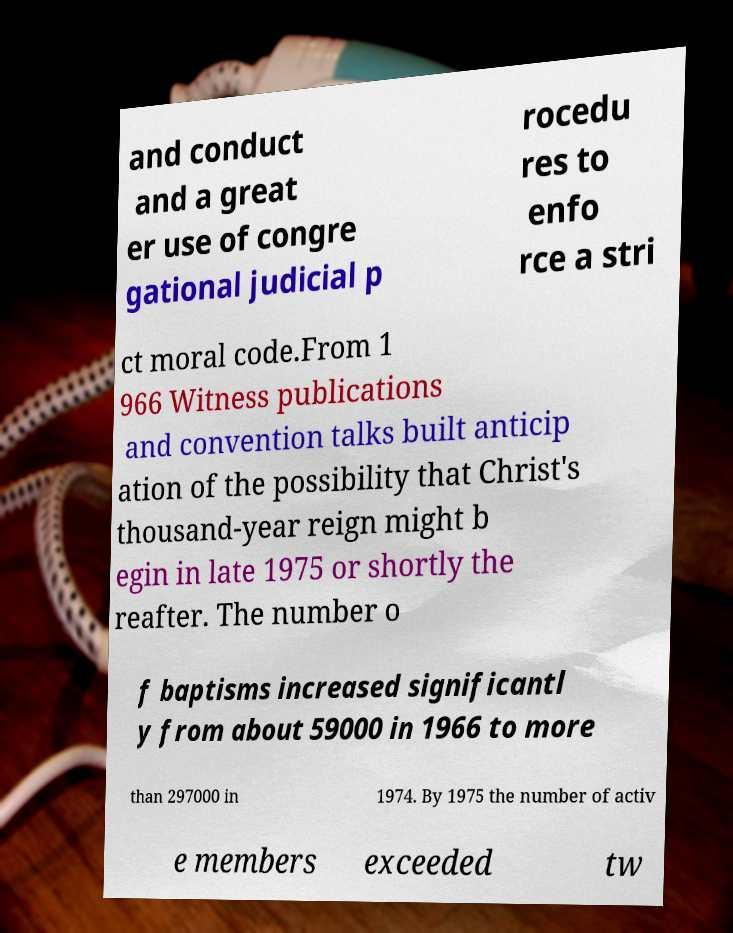What messages or text are displayed in this image? I need them in a readable, typed format. and conduct and a great er use of congre gational judicial p rocedu res to enfo rce a stri ct moral code.From 1 966 Witness publications and convention talks built anticip ation of the possibility that Christ's thousand-year reign might b egin in late 1975 or shortly the reafter. The number o f baptisms increased significantl y from about 59000 in 1966 to more than 297000 in 1974. By 1975 the number of activ e members exceeded tw 